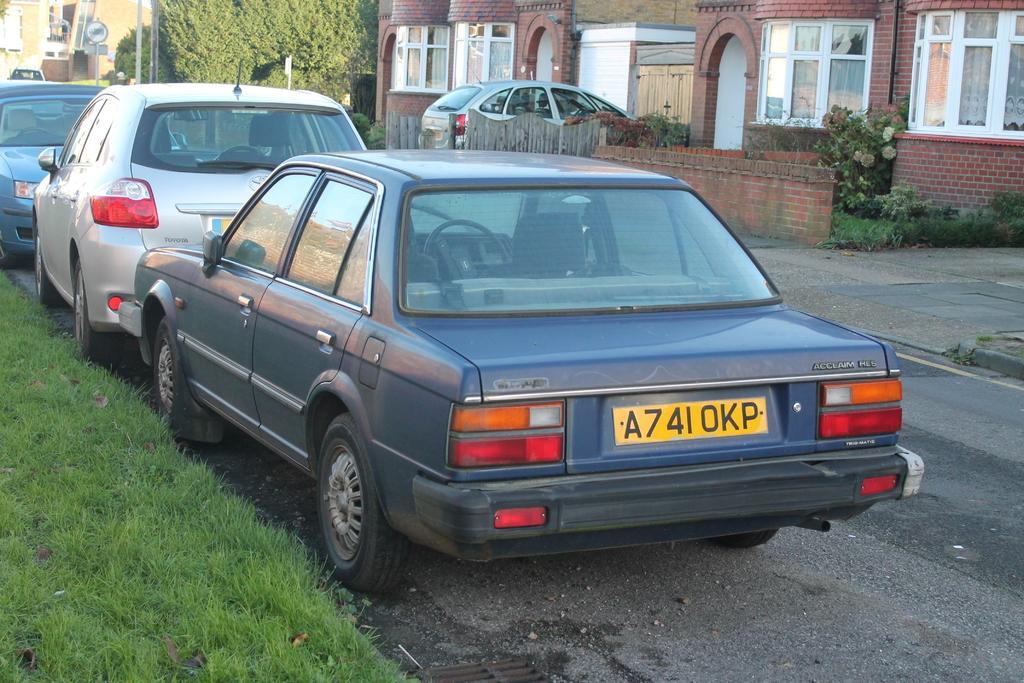Could you give a brief overview of what you see in this image? In this image we can see motor vehicles on the floor, wooden fences, buildings, sign boards, bushes and grass. 